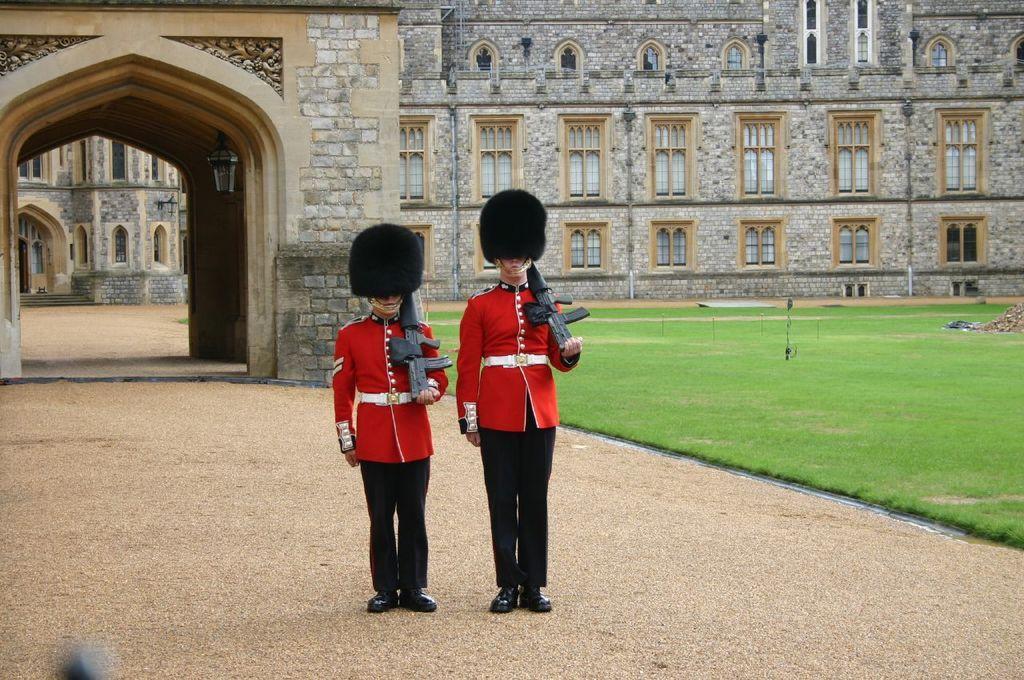Please provide a concise description of this image. Front these two people are standing and holding guns. Background we can see building, arch and grass. Lamp is attached to the wall. To this building there are windows. 